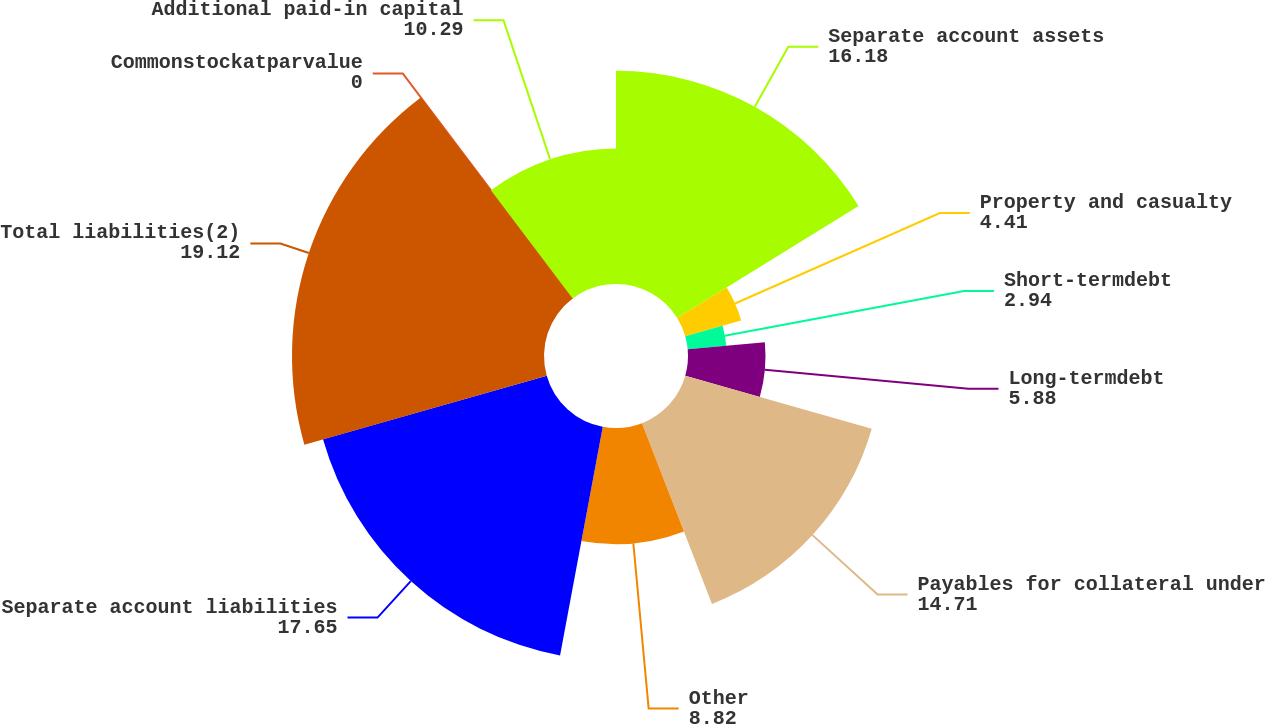<chart> <loc_0><loc_0><loc_500><loc_500><pie_chart><fcel>Separate account assets<fcel>Property and casualty<fcel>Short-termdebt<fcel>Long-termdebt<fcel>Payables for collateral under<fcel>Other<fcel>Separate account liabilities<fcel>Total liabilities(2)<fcel>Commonstockatparvalue<fcel>Additional paid-in capital<nl><fcel>16.18%<fcel>4.41%<fcel>2.94%<fcel>5.88%<fcel>14.71%<fcel>8.82%<fcel>17.65%<fcel>19.12%<fcel>0.0%<fcel>10.29%<nl></chart> 